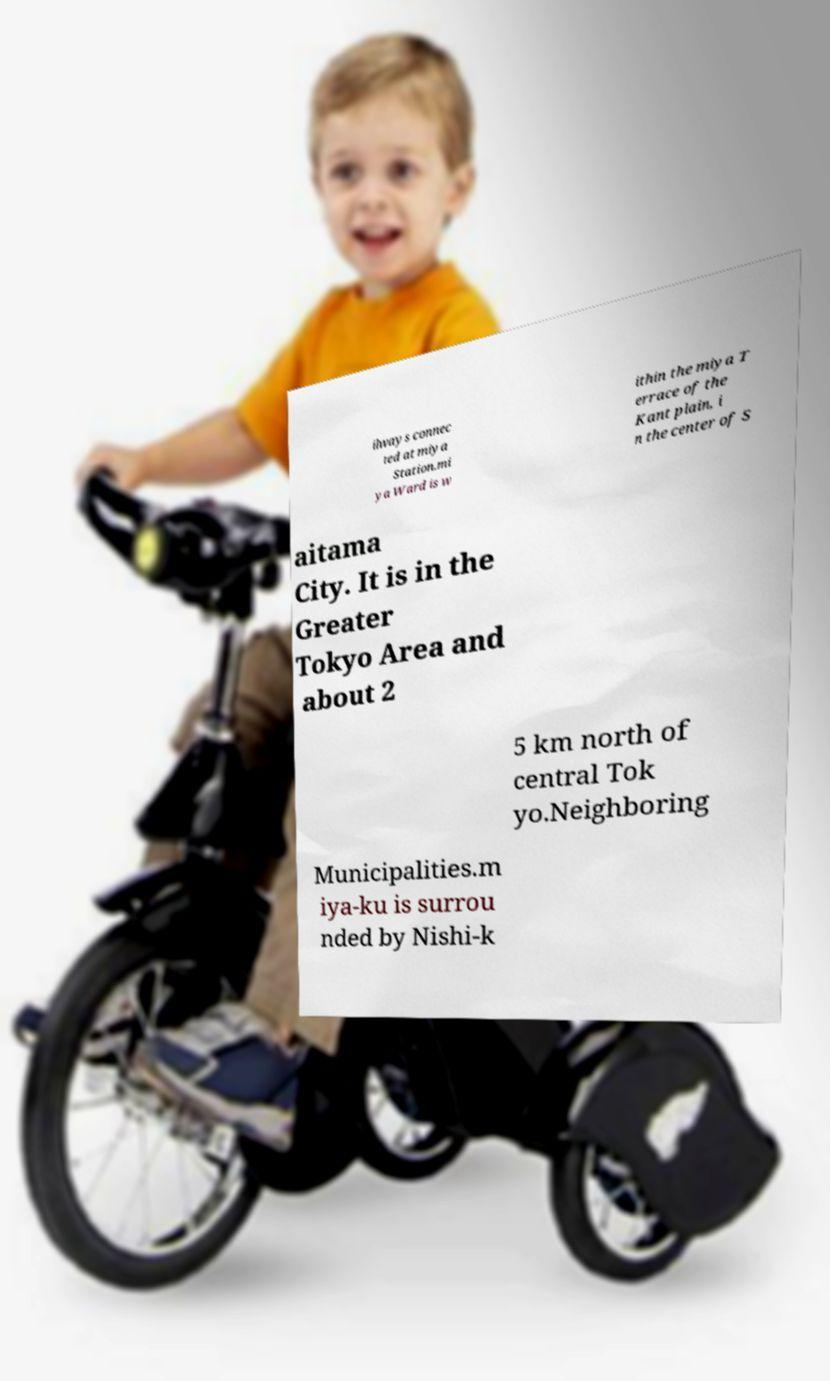I need the written content from this picture converted into text. Can you do that? ilways connec ted at miya Station.mi ya Ward is w ithin the miya T errace of the Kant plain, i n the center of S aitama City. It is in the Greater Tokyo Area and about 2 5 km north of central Tok yo.Neighboring Municipalities.m iya-ku is surrou nded by Nishi-k 